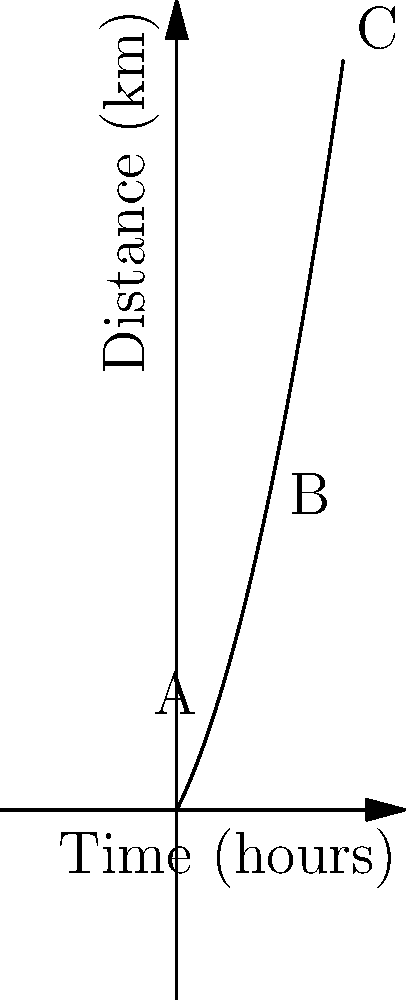In a poetic journey across varied landscapes, a character's progress is symbolized by the distance-time graph above. The curve represents the metaphorical distance traveled over time. At point B, what is the instantaneous velocity of the character's journey, and how might this relate to the symbolic terrain they are traversing? To find the instantaneous velocity at point B, we need to calculate the derivative of the distance function at that point. Let's approach this step-by-step:

1) The graph appears to follow a quadratic function. Let's assume the function is of the form:
   $$d(t) = at^2 + bt + c$$

2) We can determine the coefficients by using the points on the graph:
   Point A: (1, 3.5)
   Point B: (3, 13.5)
   Point C: (5, 27.5)

3) Substituting these points into the quadratic equation:
   $$3.5 = a(1)^2 + b(1) + c$$
   $$13.5 = a(3)^2 + b(3) + c$$
   $$27.5 = a(5)^2 + b(5) + c$$

4) Solving this system of equations (which is omitted for brevity), we get:
   $$d(t) = 0.5t^2 + 2t + 1$$

5) The instantaneous velocity is the derivative of the distance function:
   $$v(t) = \frac{d}{dt}(d(t)) = t + 2$$

6) At point B, t = 3, so the instantaneous velocity is:
   $$v(3) = 3 + 2 = 5 \text{ km/h}$$

Symbolically, this increasing velocity could represent the character's growing comfort with their journey, or perhaps a transition from a challenging terrain (like dense forests) to an easier one (like open plains).
Answer: 5 km/h 